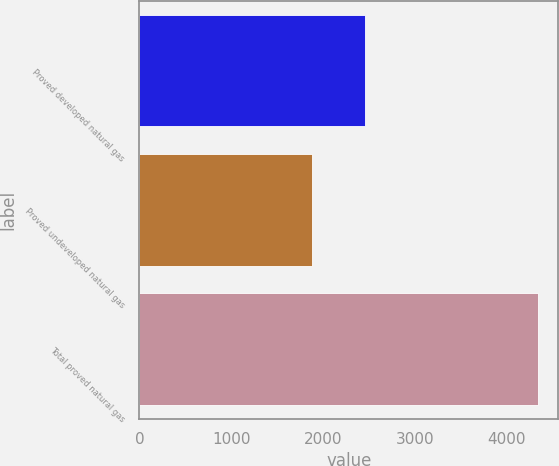Convert chart to OTSL. <chart><loc_0><loc_0><loc_500><loc_500><bar_chart><fcel>Proved developed natural gas<fcel>Proved undeveloped natural gas<fcel>Total proved natural gas<nl><fcel>2456<fcel>1883<fcel>4339<nl></chart> 